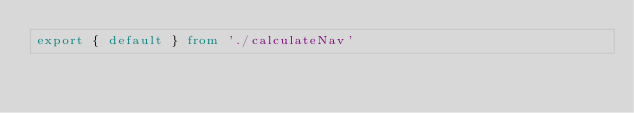Convert code to text. <code><loc_0><loc_0><loc_500><loc_500><_TypeScript_>export { default } from './calculateNav'
</code> 